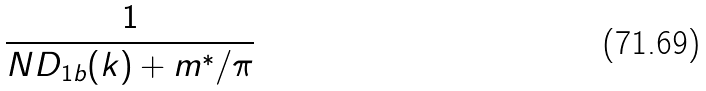<formula> <loc_0><loc_0><loc_500><loc_500>\frac { 1 } { N D _ { 1 b } ( k ) + m ^ { \ast } / \pi }</formula> 